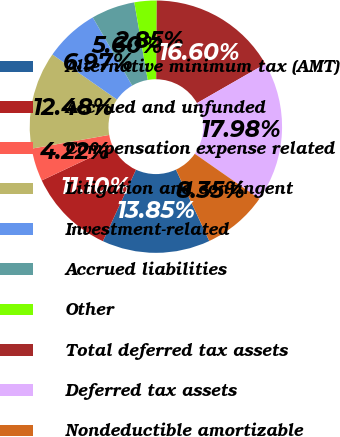<chart> <loc_0><loc_0><loc_500><loc_500><pie_chart><fcel>Alternative minimum tax (AMT)<fcel>Accrued and unfunded<fcel>Compensation expense related<fcel>Litigation and contingent<fcel>Investment-related<fcel>Accrued liabilities<fcel>Other<fcel>Total deferred tax assets<fcel>Deferred tax assets<fcel>Nondeductible amortizable<nl><fcel>13.85%<fcel>11.1%<fcel>4.22%<fcel>12.48%<fcel>6.97%<fcel>5.6%<fcel>2.85%<fcel>16.6%<fcel>17.98%<fcel>8.35%<nl></chart> 